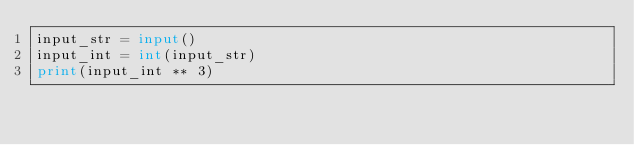<code> <loc_0><loc_0><loc_500><loc_500><_Python_>input_str = input()
input_int = int(input_str)
print(input_int ** 3)

</code> 